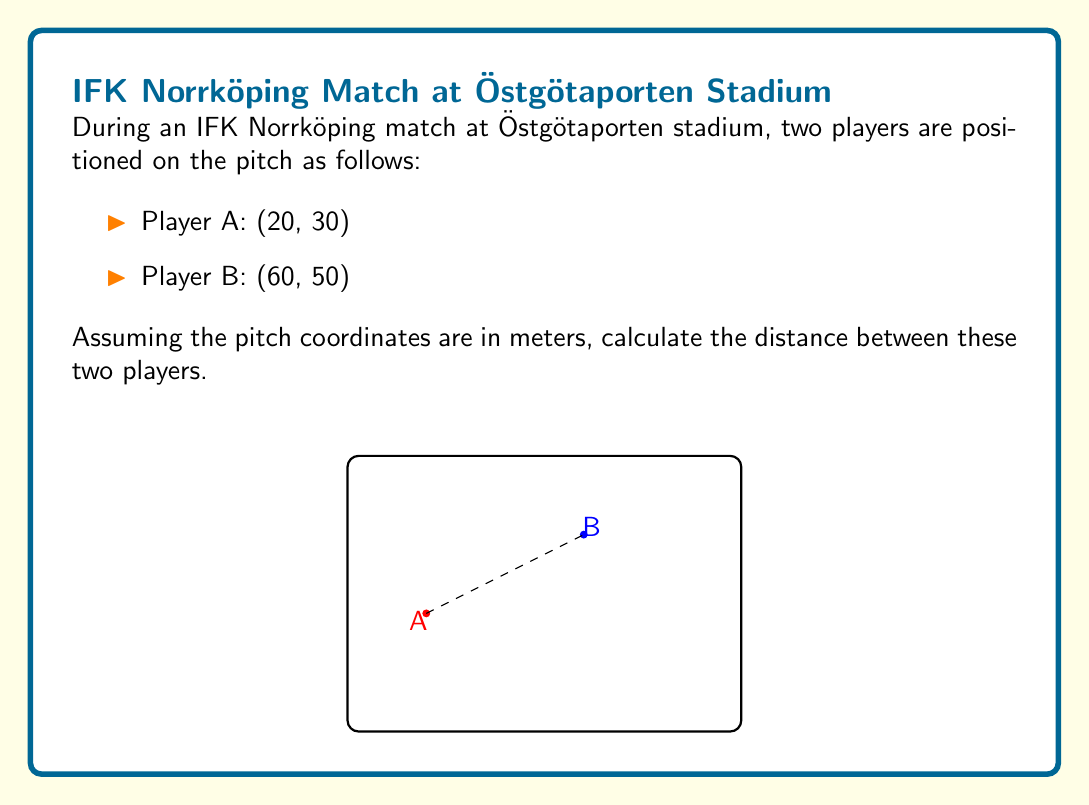Can you solve this math problem? To calculate the distance between two points in a coordinate system, we use the distance formula derived from the Pythagorean theorem:

$$ d = \sqrt{(x_2 - x_1)^2 + (y_2 - y_1)^2} $$

Where $(x_1, y_1)$ are the coordinates of the first point and $(x_2, y_2)$ are the coordinates of the second point.

Given:
Player A: $(x_1, y_1) = (20, 30)$
Player B: $(x_2, y_2) = (60, 50)$

Let's substitute these values into the formula:

$$ d = \sqrt{(60 - 20)^2 + (50 - 30)^2} $$

Now, let's solve step-by-step:

1) Simplify the expressions inside the parentheses:
   $$ d = \sqrt{(40)^2 + (20)^2} $$

2) Calculate the squares:
   $$ d = \sqrt{1600 + 400} $$

3) Add the values under the square root:
   $$ d = \sqrt{2000} $$

4) Simplify the square root:
   $$ d = 10\sqrt{20} $$

5) The square root of 20 can be simplified further:
   $$ d = 10\sqrt{4 \cdot 5} = 10 \cdot 2\sqrt{5} = 20\sqrt{5} $$

Therefore, the distance between the two players is $20\sqrt{5}$ meters.
Answer: $20\sqrt{5}$ meters 